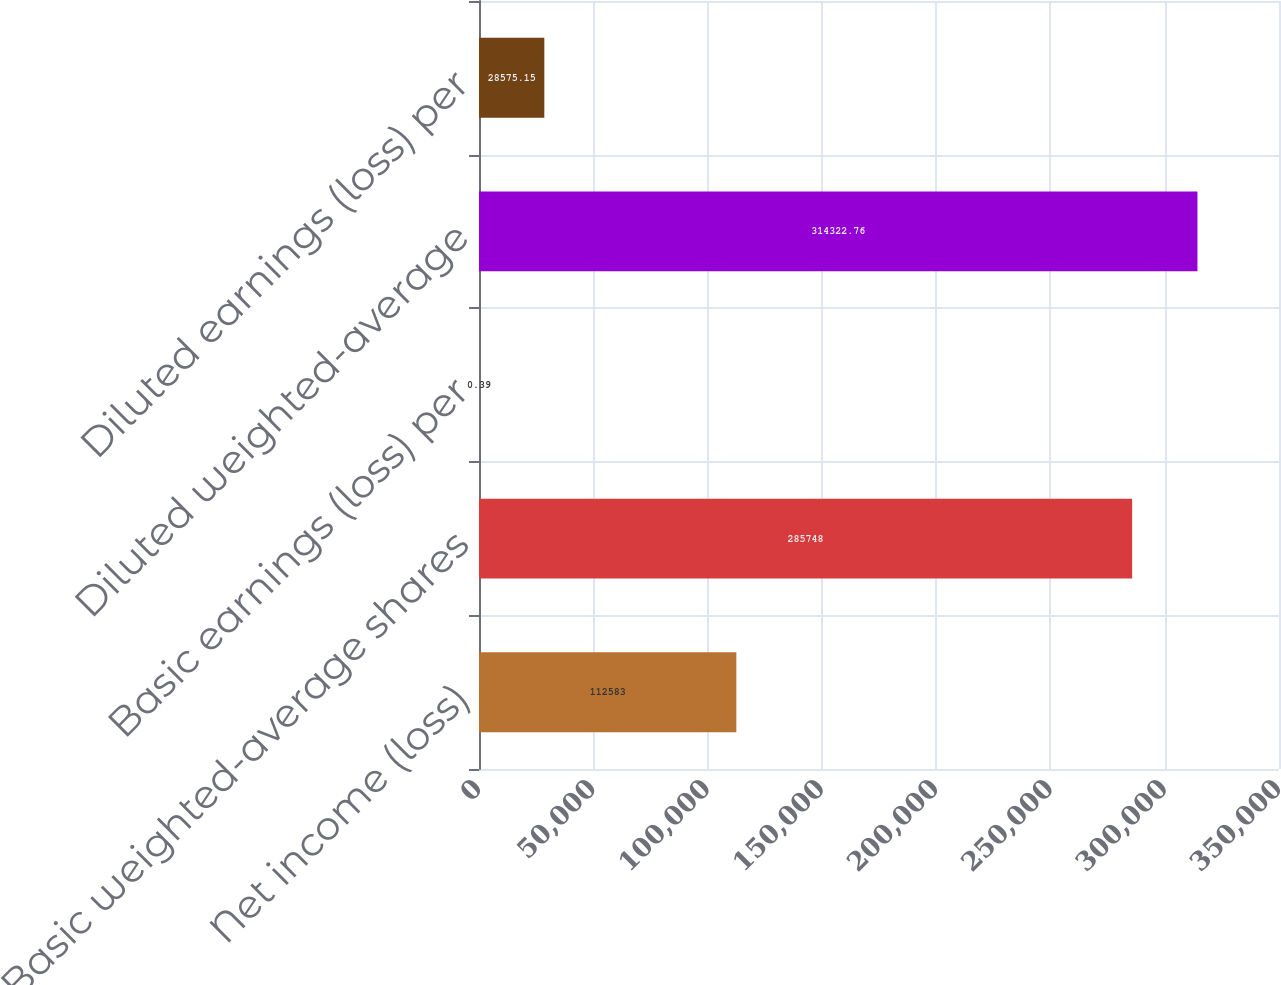Convert chart. <chart><loc_0><loc_0><loc_500><loc_500><bar_chart><fcel>Net income (loss)<fcel>Basic weighted-average shares<fcel>Basic earnings (loss) per<fcel>Diluted weighted-average<fcel>Diluted earnings (loss) per<nl><fcel>112583<fcel>285748<fcel>0.39<fcel>314323<fcel>28575.2<nl></chart> 